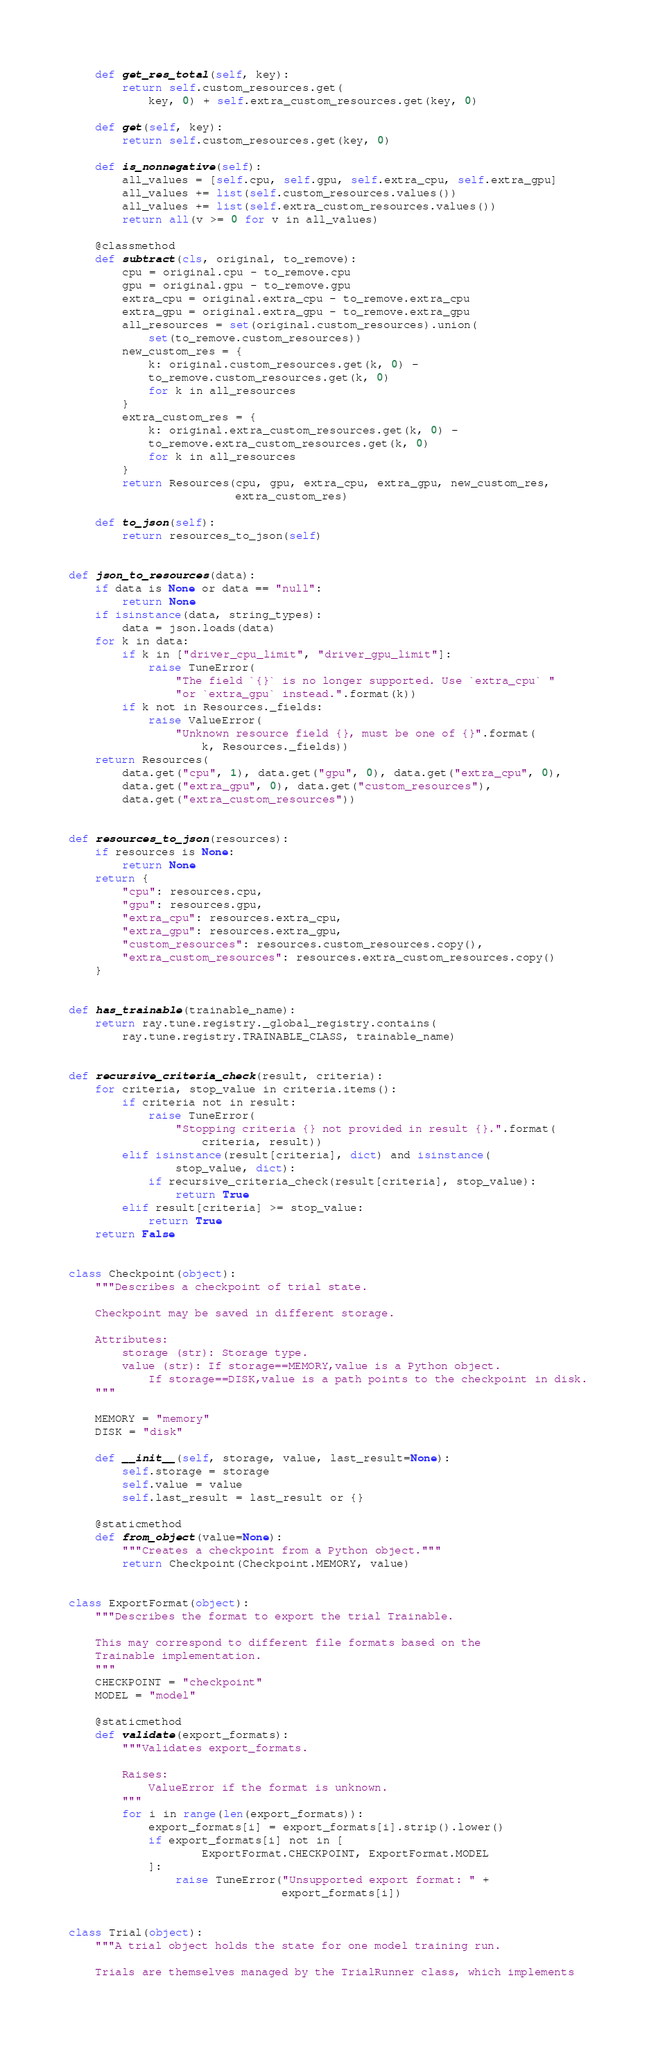Convert code to text. <code><loc_0><loc_0><loc_500><loc_500><_Python_>
    def get_res_total(self, key):
        return self.custom_resources.get(
            key, 0) + self.extra_custom_resources.get(key, 0)

    def get(self, key):
        return self.custom_resources.get(key, 0)

    def is_nonnegative(self):
        all_values = [self.cpu, self.gpu, self.extra_cpu, self.extra_gpu]
        all_values += list(self.custom_resources.values())
        all_values += list(self.extra_custom_resources.values())
        return all(v >= 0 for v in all_values)

    @classmethod
    def subtract(cls, original, to_remove):
        cpu = original.cpu - to_remove.cpu
        gpu = original.gpu - to_remove.gpu
        extra_cpu = original.extra_cpu - to_remove.extra_cpu
        extra_gpu = original.extra_gpu - to_remove.extra_gpu
        all_resources = set(original.custom_resources).union(
            set(to_remove.custom_resources))
        new_custom_res = {
            k: original.custom_resources.get(k, 0) -
            to_remove.custom_resources.get(k, 0)
            for k in all_resources
        }
        extra_custom_res = {
            k: original.extra_custom_resources.get(k, 0) -
            to_remove.extra_custom_resources.get(k, 0)
            for k in all_resources
        }
        return Resources(cpu, gpu, extra_cpu, extra_gpu, new_custom_res,
                         extra_custom_res)

    def to_json(self):
        return resources_to_json(self)


def json_to_resources(data):
    if data is None or data == "null":
        return None
    if isinstance(data, string_types):
        data = json.loads(data)
    for k in data:
        if k in ["driver_cpu_limit", "driver_gpu_limit"]:
            raise TuneError(
                "The field `{}` is no longer supported. Use `extra_cpu` "
                "or `extra_gpu` instead.".format(k))
        if k not in Resources._fields:
            raise ValueError(
                "Unknown resource field {}, must be one of {}".format(
                    k, Resources._fields))
    return Resources(
        data.get("cpu", 1), data.get("gpu", 0), data.get("extra_cpu", 0),
        data.get("extra_gpu", 0), data.get("custom_resources"),
        data.get("extra_custom_resources"))


def resources_to_json(resources):
    if resources is None:
        return None
    return {
        "cpu": resources.cpu,
        "gpu": resources.gpu,
        "extra_cpu": resources.extra_cpu,
        "extra_gpu": resources.extra_gpu,
        "custom_resources": resources.custom_resources.copy(),
        "extra_custom_resources": resources.extra_custom_resources.copy()
    }


def has_trainable(trainable_name):
    return ray.tune.registry._global_registry.contains(
        ray.tune.registry.TRAINABLE_CLASS, trainable_name)


def recursive_criteria_check(result, criteria):
    for criteria, stop_value in criteria.items():
        if criteria not in result:
            raise TuneError(
                "Stopping criteria {} not provided in result {}.".format(
                    criteria, result))
        elif isinstance(result[criteria], dict) and isinstance(
                stop_value, dict):
            if recursive_criteria_check(result[criteria], stop_value):
                return True
        elif result[criteria] >= stop_value:
            return True
    return False


class Checkpoint(object):
    """Describes a checkpoint of trial state.

    Checkpoint may be saved in different storage.

    Attributes:
        storage (str): Storage type.
        value (str): If storage==MEMORY,value is a Python object.
            If storage==DISK,value is a path points to the checkpoint in disk.
    """

    MEMORY = "memory"
    DISK = "disk"

    def __init__(self, storage, value, last_result=None):
        self.storage = storage
        self.value = value
        self.last_result = last_result or {}

    @staticmethod
    def from_object(value=None):
        """Creates a checkpoint from a Python object."""
        return Checkpoint(Checkpoint.MEMORY, value)


class ExportFormat(object):
    """Describes the format to export the trial Trainable.

    This may correspond to different file formats based on the
    Trainable implementation.
    """
    CHECKPOINT = "checkpoint"
    MODEL = "model"

    @staticmethod
    def validate(export_formats):
        """Validates export_formats.

        Raises:
            ValueError if the format is unknown.
        """
        for i in range(len(export_formats)):
            export_formats[i] = export_formats[i].strip().lower()
            if export_formats[i] not in [
                    ExportFormat.CHECKPOINT, ExportFormat.MODEL
            ]:
                raise TuneError("Unsupported export format: " +
                                export_formats[i])


class Trial(object):
    """A trial object holds the state for one model training run.

    Trials are themselves managed by the TrialRunner class, which implements</code> 